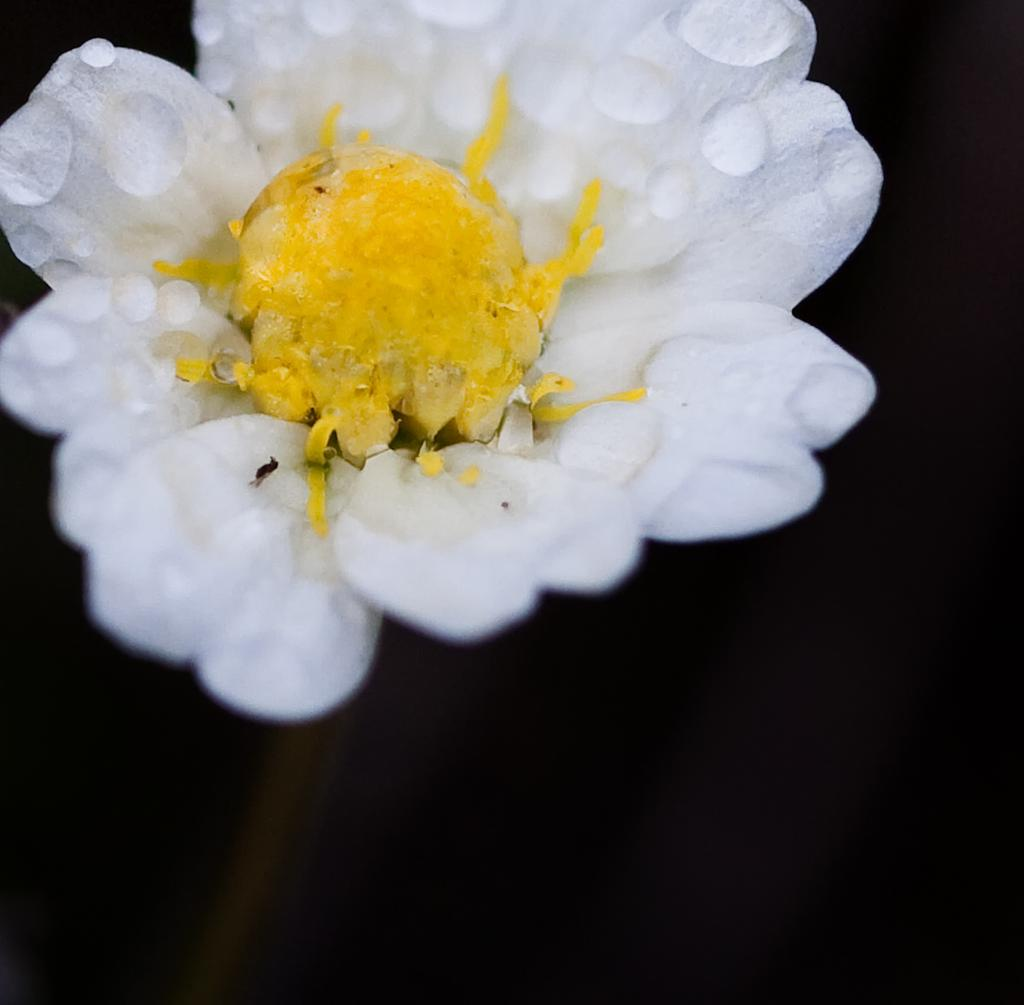What type of flower is in the image? There is a white color flower in the image. Can you describe the appearance of the flower? The flower has water droplets on it. What is the color of the background in the image? The background of the image is black. What type of leather material is used to make the pan in the image? There is no pan present in the image, so it's not possible to determine what type of leather material might be used. 